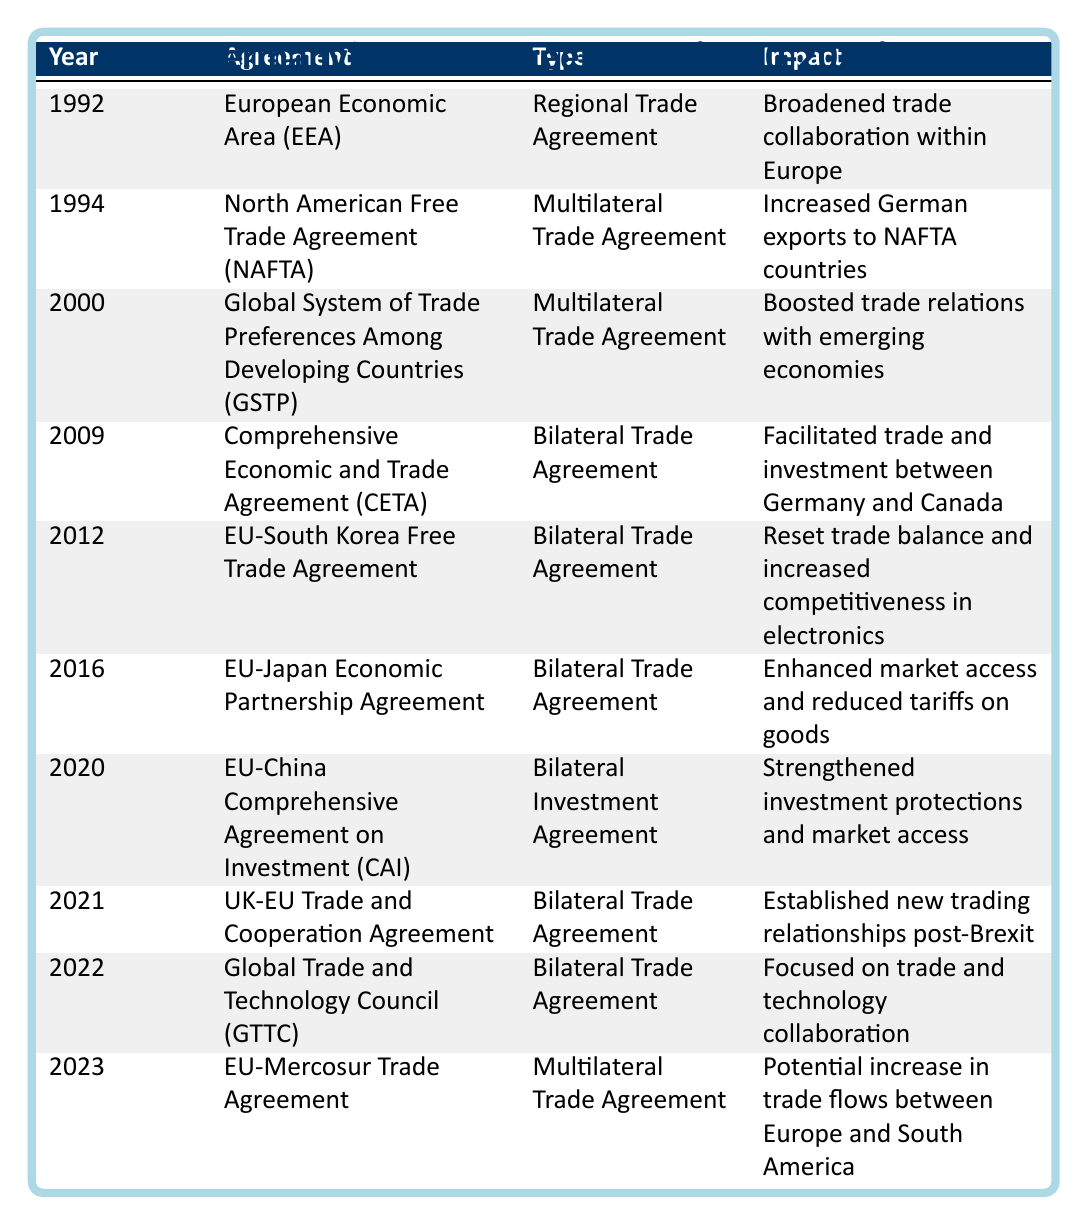What year was the EU-South Korea Free Trade Agreement signed? The table lists the EU-South Korea Free Trade Agreement under the year 2012.
Answer: 2012 Which trade agreement aimed to enhance market access with Japan? The trade agreement focused on Japan and enhancing market access is the EU-Japan Economic Partnership Agreement, listed in 2016.
Answer: EU-Japan Economic Partnership Agreement How many bilateral trade agreements were signed by Germany from 2009 to 2023? The table shows bilateral trade agreements in 2009, 2012, 2016, 2020, 2021, and 2022, totaling 6 agreements.
Answer: 6 Did Germany sign any trade agreements with emerging economies? The table indicates that the Global System of Trade Preferences Among Developing Countries (GSTP) was signed in 2000, which promotes trade relations with developing economies.
Answer: Yes Which agreement was signed in 2020, and what was its main impact? The EU-China Comprehensive Agreement on Investment (CAI) was signed in 2020, with the main impact of strengthening investment protections and market access.
Answer: EU-China Comprehensive Agreement on Investment; strengthen investment protections What is the most recent trade agreement listed in the table? The table provides information that the most recent trade agreement signed by Germany is the EU-Mercosur Trade Agreement from the year 2023.
Answer: EU-Mercosur Trade Agreement How many trade agreements were signed between 1990 and 2000? Looking at the years from 1990 to 2000, the table shows that Germany signed 3 trade agreements: EEA in 1992, NAFTA in 1994, and GSTP in 2000.
Answer: 3 What is the impact of the Comprehensive Economic and Trade Agreement (CETA)? The table states that CETA, signed in 2009, facilitated trade and investment between Germany and Canada, thereby impacting their economic relations positively.
Answer: Facilitated trade and investment Which trade agreement emphasized collaboration on technology, and in what year was it signed? The table indicates that the Global Trade and Technology Council (GTTC) emphasizes technology collaboration and was signed in 2022.
Answer: Global Trade and Technology Council; 2022 How many multilateral trade agreements were signed by Germany between 2000 and 2023? Reviewing the agreements, the GSTP in 2000, the EU-Mercosur Trade Agreement in 2023, and the inclusion of NAFTA in 1994 (although it included multiple countries), totals 3 multilateral agreements.
Answer: 3 Which agreement increased German exports to NAFTA countries? According to the table, the North American Free Trade Agreement (NAFTA), signed in 1994, specifically increased German exports to these countries.
Answer: North American Free Trade Agreement (NAFTA) 